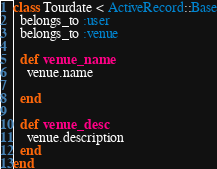Convert code to text. <code><loc_0><loc_0><loc_500><loc_500><_Ruby_>class Tourdate < ActiveRecord::Base
  belongs_to :user
  belongs_to :venue

  def venue_name
    venue.name
  
  end
  
  def venue_desc
    venue.description
  end
end</code> 